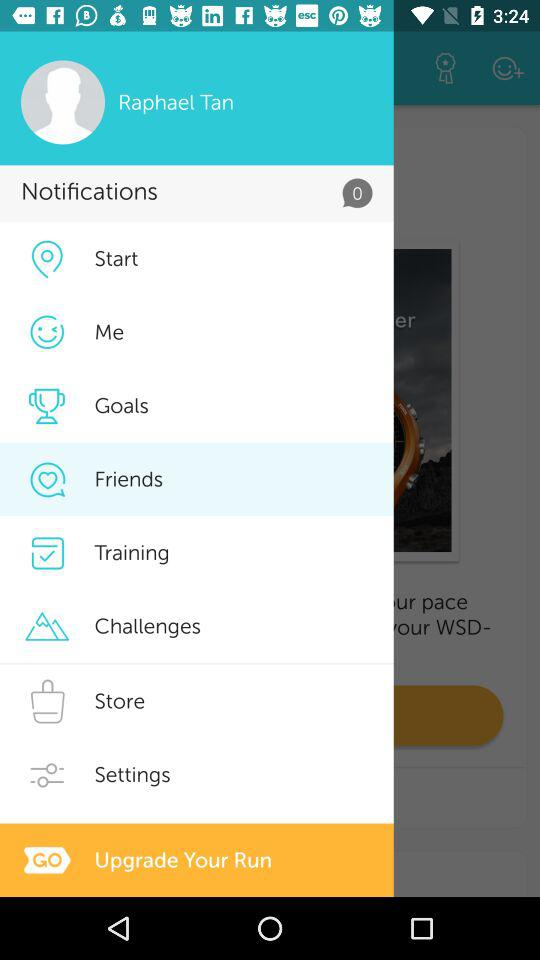What is the name of the user? The name of the user is Raphael Tan. 